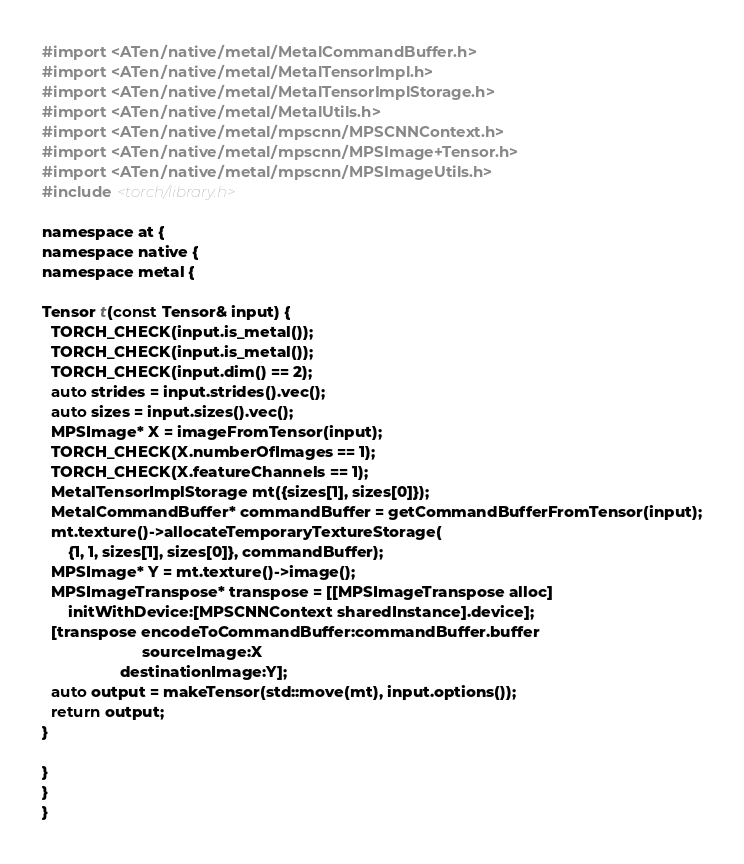<code> <loc_0><loc_0><loc_500><loc_500><_ObjectiveC_>#import <ATen/native/metal/MetalCommandBuffer.h>
#import <ATen/native/metal/MetalTensorImpl.h>
#import <ATen/native/metal/MetalTensorImplStorage.h>
#import <ATen/native/metal/MetalUtils.h>
#import <ATen/native/metal/mpscnn/MPSCNNContext.h>
#import <ATen/native/metal/mpscnn/MPSImage+Tensor.h>
#import <ATen/native/metal/mpscnn/MPSImageUtils.h>
#include <torch/library.h>

namespace at {
namespace native {
namespace metal {

Tensor t(const Tensor& input) {
  TORCH_CHECK(input.is_metal());
  TORCH_CHECK(input.is_metal());
  TORCH_CHECK(input.dim() == 2);
  auto strides = input.strides().vec();
  auto sizes = input.sizes().vec();
  MPSImage* X = imageFromTensor(input);
  TORCH_CHECK(X.numberOfImages == 1);
  TORCH_CHECK(X.featureChannels == 1);
  MetalTensorImplStorage mt({sizes[1], sizes[0]});
  MetalCommandBuffer* commandBuffer = getCommandBufferFromTensor(input);
  mt.texture()->allocateTemporaryTextureStorage(
      {1, 1, sizes[1], sizes[0]}, commandBuffer);
  MPSImage* Y = mt.texture()->image();
  MPSImageTranspose* transpose = [[MPSImageTranspose alloc]
      initWithDevice:[MPSCNNContext sharedInstance].device];
  [transpose encodeToCommandBuffer:commandBuffer.buffer
                       sourceImage:X
                  destinationImage:Y];
  auto output = makeTensor(std::move(mt), input.options());
  return output;
}

}
}
}
</code> 